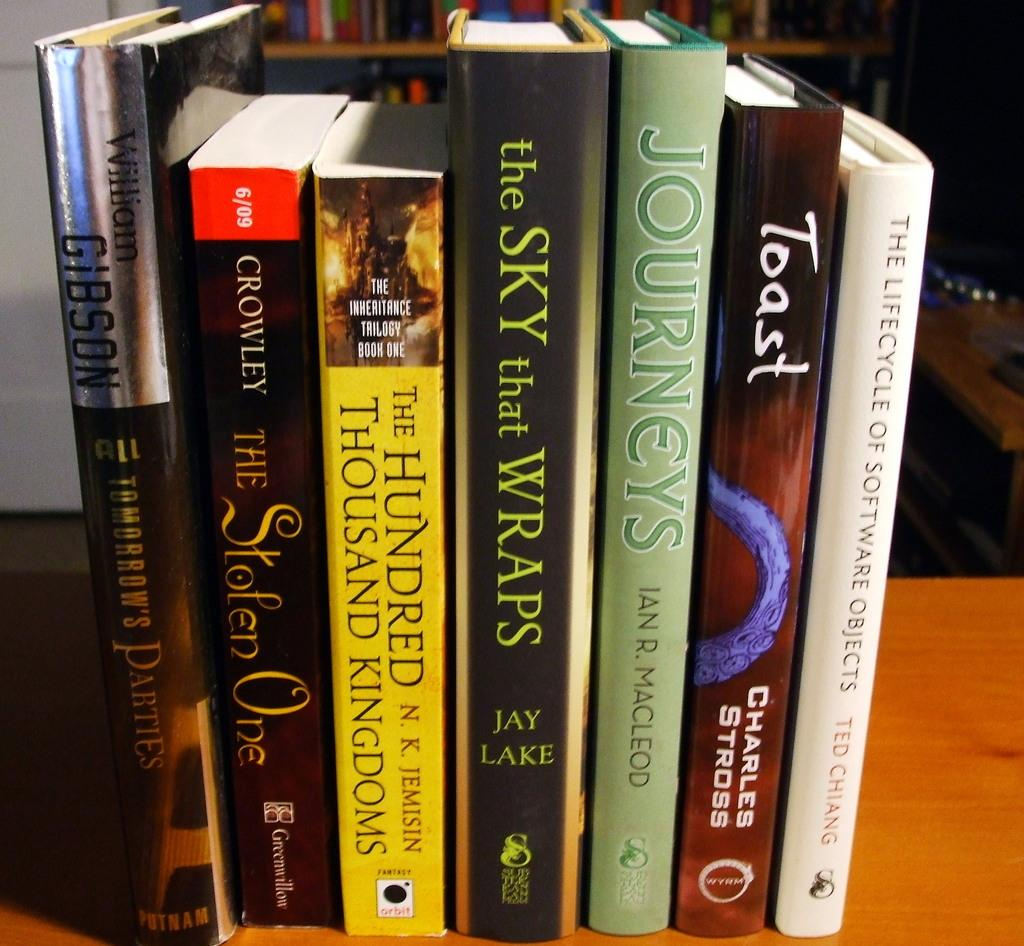<image>
Relay a brief, clear account of the picture shown. a row of books that says 'the sky that wraps' 